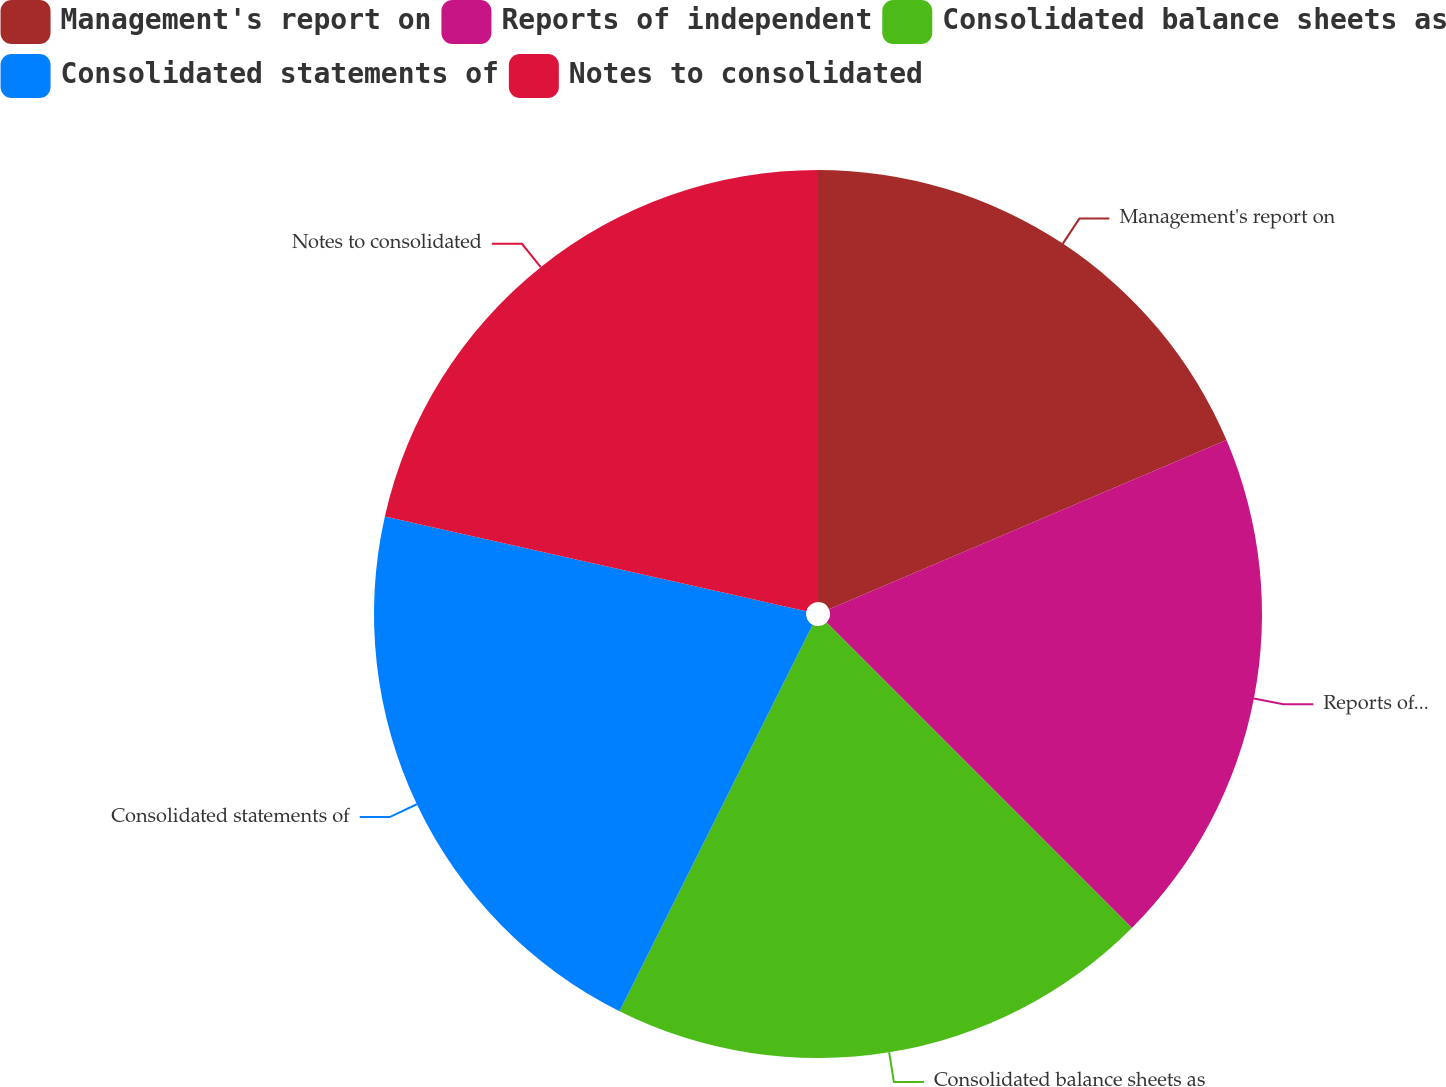Convert chart to OTSL. <chart><loc_0><loc_0><loc_500><loc_500><pie_chart><fcel>Management's report on<fcel>Reports of independent<fcel>Consolidated balance sheets as<fcel>Consolidated statements of<fcel>Notes to consolidated<nl><fcel>18.59%<fcel>18.91%<fcel>19.87%<fcel>21.15%<fcel>21.47%<nl></chart> 